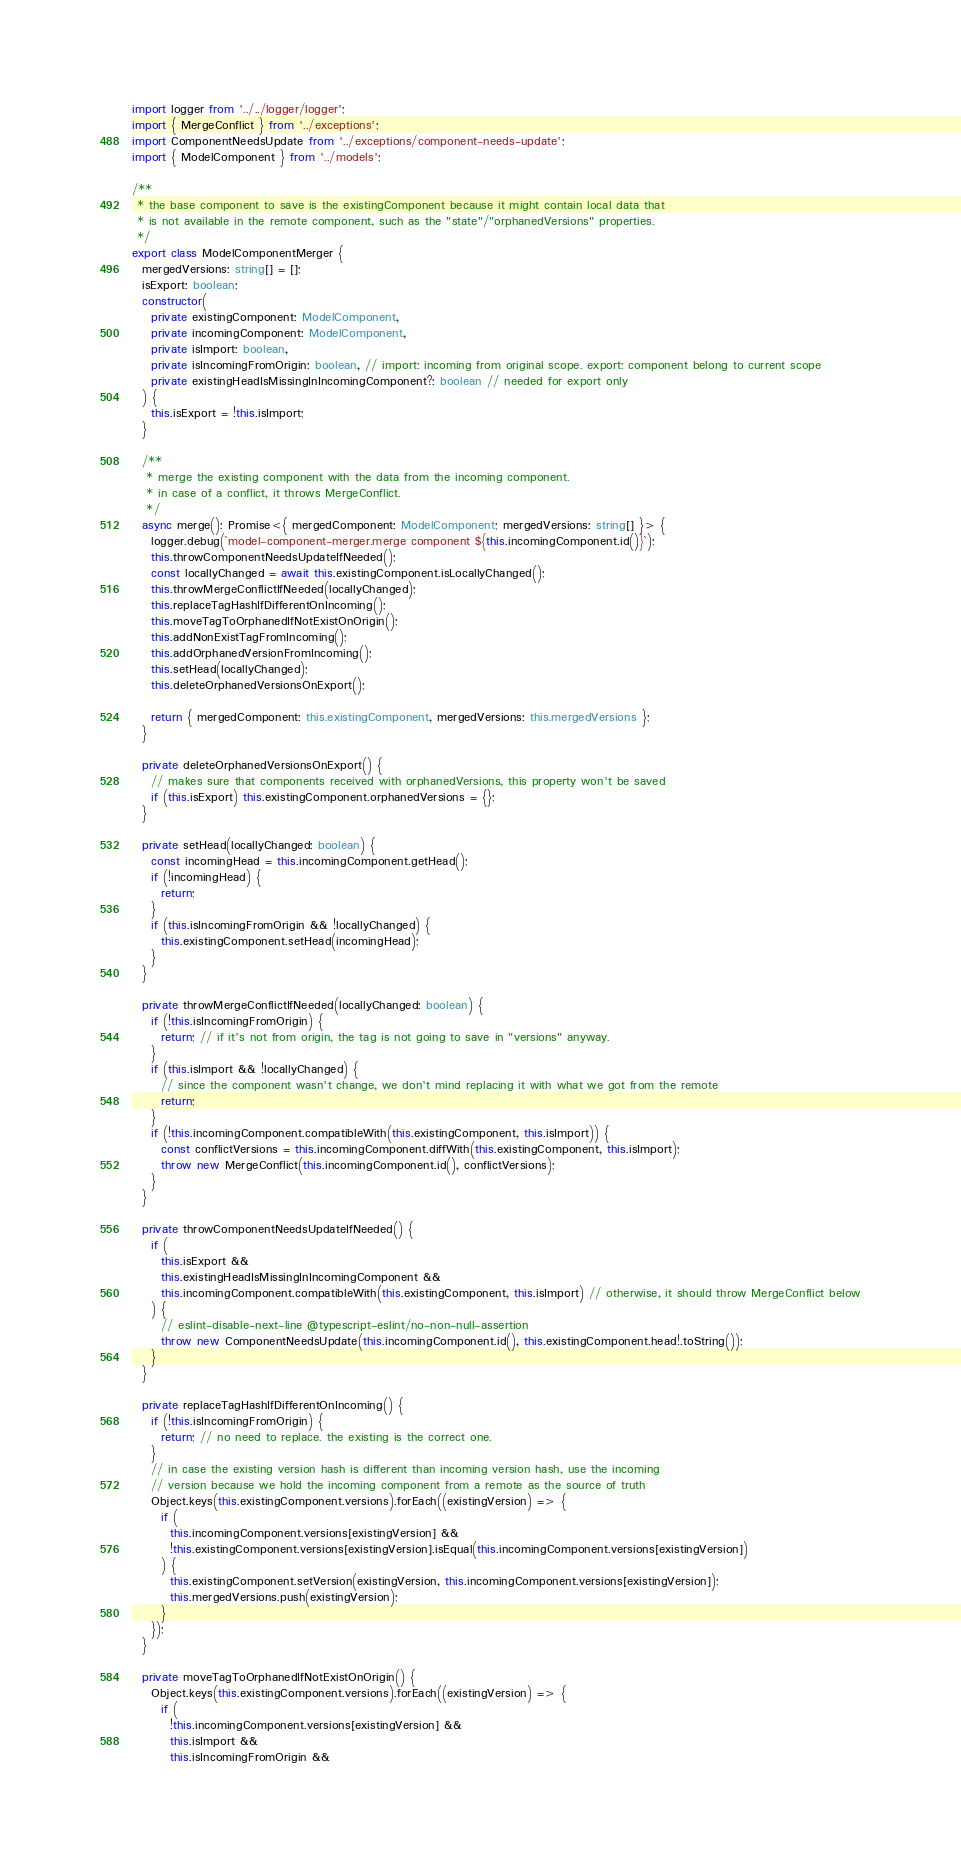Convert code to text. <code><loc_0><loc_0><loc_500><loc_500><_TypeScript_>import logger from '../../logger/logger';
import { MergeConflict } from '../exceptions';
import ComponentNeedsUpdate from '../exceptions/component-needs-update';
import { ModelComponent } from '../models';

/**
 * the base component to save is the existingComponent because it might contain local data that
 * is not available in the remote component, such as the "state"/"orphanedVersions" properties.
 */
export class ModelComponentMerger {
  mergedVersions: string[] = [];
  isExport: boolean;
  constructor(
    private existingComponent: ModelComponent,
    private incomingComponent: ModelComponent,
    private isImport: boolean,
    private isIncomingFromOrigin: boolean, // import: incoming from original scope. export: component belong to current scope
    private existingHeadIsMissingInIncomingComponent?: boolean // needed for export only
  ) {
    this.isExport = !this.isImport;
  }

  /**
   * merge the existing component with the data from the incoming component.
   * in case of a conflict, it throws MergeConflict.
   */
  async merge(): Promise<{ mergedComponent: ModelComponent; mergedVersions: string[] }> {
    logger.debug(`model-component-merger.merge component ${this.incomingComponent.id()}`);
    this.throwComponentNeedsUpdateIfNeeded();
    const locallyChanged = await this.existingComponent.isLocallyChanged();
    this.throwMergeConflictIfNeeded(locallyChanged);
    this.replaceTagHashIfDifferentOnIncoming();
    this.moveTagToOrphanedIfNotExistOnOrigin();
    this.addNonExistTagFromIncoming();
    this.addOrphanedVersionFromIncoming();
    this.setHead(locallyChanged);
    this.deleteOrphanedVersionsOnExport();

    return { mergedComponent: this.existingComponent, mergedVersions: this.mergedVersions };
  }

  private deleteOrphanedVersionsOnExport() {
    // makes sure that components received with orphanedVersions, this property won't be saved
    if (this.isExport) this.existingComponent.orphanedVersions = {};
  }

  private setHead(locallyChanged: boolean) {
    const incomingHead = this.incomingComponent.getHead();
    if (!incomingHead) {
      return;
    }
    if (this.isIncomingFromOrigin && !locallyChanged) {
      this.existingComponent.setHead(incomingHead);
    }
  }

  private throwMergeConflictIfNeeded(locallyChanged: boolean) {
    if (!this.isIncomingFromOrigin) {
      return; // if it's not from origin, the tag is not going to save in "versions" anyway.
    }
    if (this.isImport && !locallyChanged) {
      // since the component wasn't change, we don't mind replacing it with what we got from the remote
      return;
    }
    if (!this.incomingComponent.compatibleWith(this.existingComponent, this.isImport)) {
      const conflictVersions = this.incomingComponent.diffWith(this.existingComponent, this.isImport);
      throw new MergeConflict(this.incomingComponent.id(), conflictVersions);
    }
  }

  private throwComponentNeedsUpdateIfNeeded() {
    if (
      this.isExport &&
      this.existingHeadIsMissingInIncomingComponent &&
      this.incomingComponent.compatibleWith(this.existingComponent, this.isImport) // otherwise, it should throw MergeConflict below
    ) {
      // eslint-disable-next-line @typescript-eslint/no-non-null-assertion
      throw new ComponentNeedsUpdate(this.incomingComponent.id(), this.existingComponent.head!.toString());
    }
  }

  private replaceTagHashIfDifferentOnIncoming() {
    if (!this.isIncomingFromOrigin) {
      return; // no need to replace. the existing is the correct one.
    }
    // in case the existing version hash is different than incoming version hash, use the incoming
    // version because we hold the incoming component from a remote as the source of truth
    Object.keys(this.existingComponent.versions).forEach((existingVersion) => {
      if (
        this.incomingComponent.versions[existingVersion] &&
        !this.existingComponent.versions[existingVersion].isEqual(this.incomingComponent.versions[existingVersion])
      ) {
        this.existingComponent.setVersion(existingVersion, this.incomingComponent.versions[existingVersion]);
        this.mergedVersions.push(existingVersion);
      }
    });
  }

  private moveTagToOrphanedIfNotExistOnOrigin() {
    Object.keys(this.existingComponent.versions).forEach((existingVersion) => {
      if (
        !this.incomingComponent.versions[existingVersion] &&
        this.isImport &&
        this.isIncomingFromOrigin &&</code> 